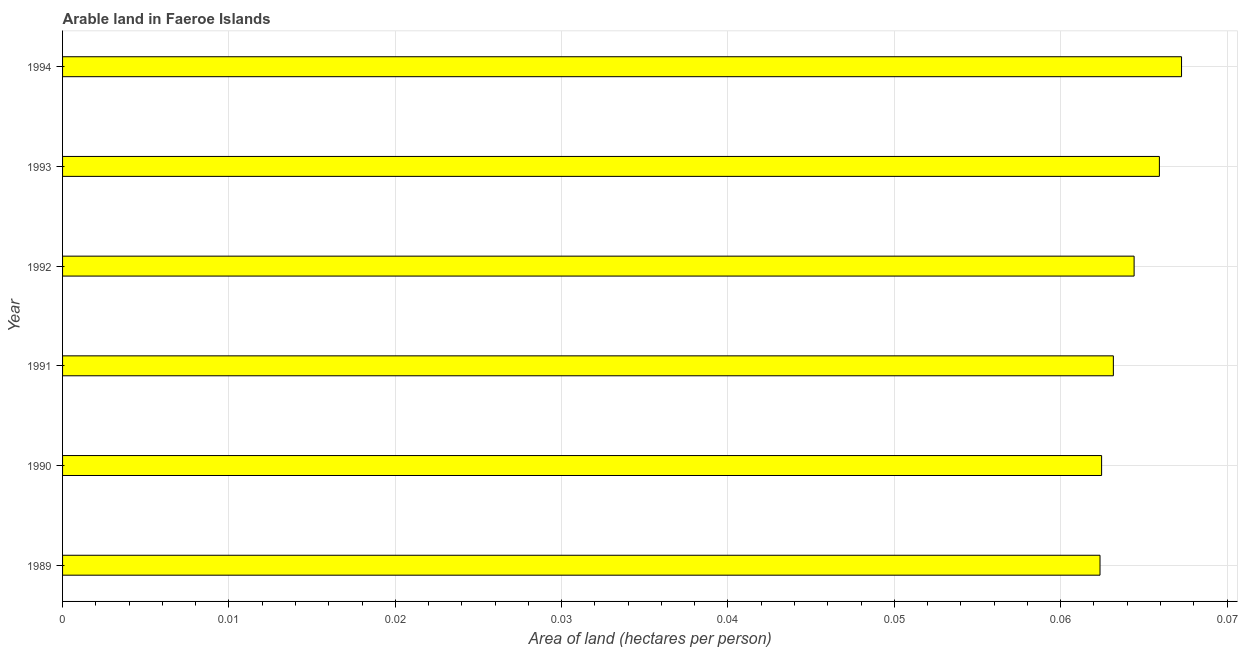Does the graph contain any zero values?
Provide a succinct answer. No. What is the title of the graph?
Keep it short and to the point. Arable land in Faeroe Islands. What is the label or title of the X-axis?
Your answer should be compact. Area of land (hectares per person). What is the area of arable land in 1993?
Your response must be concise. 0.07. Across all years, what is the maximum area of arable land?
Offer a terse response. 0.07. Across all years, what is the minimum area of arable land?
Offer a very short reply. 0.06. What is the sum of the area of arable land?
Provide a short and direct response. 0.39. What is the difference between the area of arable land in 1990 and 1992?
Keep it short and to the point. -0. What is the average area of arable land per year?
Make the answer very short. 0.06. What is the median area of arable land?
Provide a short and direct response. 0.06. What is the ratio of the area of arable land in 1992 to that in 1994?
Provide a succinct answer. 0.96. Is the difference between the area of arable land in 1991 and 1993 greater than the difference between any two years?
Your answer should be compact. No. Are all the bars in the graph horizontal?
Your answer should be very brief. Yes. What is the difference between two consecutive major ticks on the X-axis?
Ensure brevity in your answer.  0.01. Are the values on the major ticks of X-axis written in scientific E-notation?
Offer a very short reply. No. What is the Area of land (hectares per person) of 1989?
Provide a succinct answer. 0.06. What is the Area of land (hectares per person) in 1990?
Your response must be concise. 0.06. What is the Area of land (hectares per person) in 1991?
Make the answer very short. 0.06. What is the Area of land (hectares per person) in 1992?
Keep it short and to the point. 0.06. What is the Area of land (hectares per person) of 1993?
Provide a succinct answer. 0.07. What is the Area of land (hectares per person) of 1994?
Ensure brevity in your answer.  0.07. What is the difference between the Area of land (hectares per person) in 1989 and 1990?
Your answer should be very brief. -0. What is the difference between the Area of land (hectares per person) in 1989 and 1991?
Provide a short and direct response. -0. What is the difference between the Area of land (hectares per person) in 1989 and 1992?
Provide a short and direct response. -0. What is the difference between the Area of land (hectares per person) in 1989 and 1993?
Ensure brevity in your answer.  -0. What is the difference between the Area of land (hectares per person) in 1989 and 1994?
Make the answer very short. -0. What is the difference between the Area of land (hectares per person) in 1990 and 1991?
Keep it short and to the point. -0. What is the difference between the Area of land (hectares per person) in 1990 and 1992?
Your answer should be very brief. -0. What is the difference between the Area of land (hectares per person) in 1990 and 1993?
Your answer should be very brief. -0. What is the difference between the Area of land (hectares per person) in 1990 and 1994?
Offer a very short reply. -0. What is the difference between the Area of land (hectares per person) in 1991 and 1992?
Your answer should be very brief. -0. What is the difference between the Area of land (hectares per person) in 1991 and 1993?
Offer a very short reply. -0. What is the difference between the Area of land (hectares per person) in 1991 and 1994?
Give a very brief answer. -0. What is the difference between the Area of land (hectares per person) in 1992 and 1993?
Offer a very short reply. -0. What is the difference between the Area of land (hectares per person) in 1992 and 1994?
Make the answer very short. -0. What is the difference between the Area of land (hectares per person) in 1993 and 1994?
Ensure brevity in your answer.  -0. What is the ratio of the Area of land (hectares per person) in 1989 to that in 1990?
Offer a terse response. 1. What is the ratio of the Area of land (hectares per person) in 1989 to that in 1993?
Give a very brief answer. 0.95. What is the ratio of the Area of land (hectares per person) in 1989 to that in 1994?
Provide a short and direct response. 0.93. What is the ratio of the Area of land (hectares per person) in 1990 to that in 1992?
Offer a terse response. 0.97. What is the ratio of the Area of land (hectares per person) in 1990 to that in 1993?
Offer a very short reply. 0.95. What is the ratio of the Area of land (hectares per person) in 1990 to that in 1994?
Offer a very short reply. 0.93. What is the ratio of the Area of land (hectares per person) in 1991 to that in 1993?
Your answer should be very brief. 0.96. What is the ratio of the Area of land (hectares per person) in 1991 to that in 1994?
Provide a short and direct response. 0.94. What is the ratio of the Area of land (hectares per person) in 1992 to that in 1993?
Provide a short and direct response. 0.98. What is the ratio of the Area of land (hectares per person) in 1992 to that in 1994?
Your answer should be very brief. 0.96. 